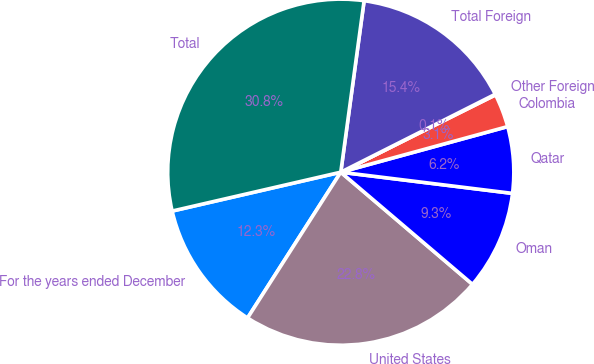Convert chart to OTSL. <chart><loc_0><loc_0><loc_500><loc_500><pie_chart><fcel>For the years ended December<fcel>United States<fcel>Oman<fcel>Qatar<fcel>Colombia<fcel>Other Foreign<fcel>Total Foreign<fcel>Total<nl><fcel>12.34%<fcel>22.83%<fcel>9.27%<fcel>6.2%<fcel>3.13%<fcel>0.06%<fcel>15.41%<fcel>30.76%<nl></chart> 